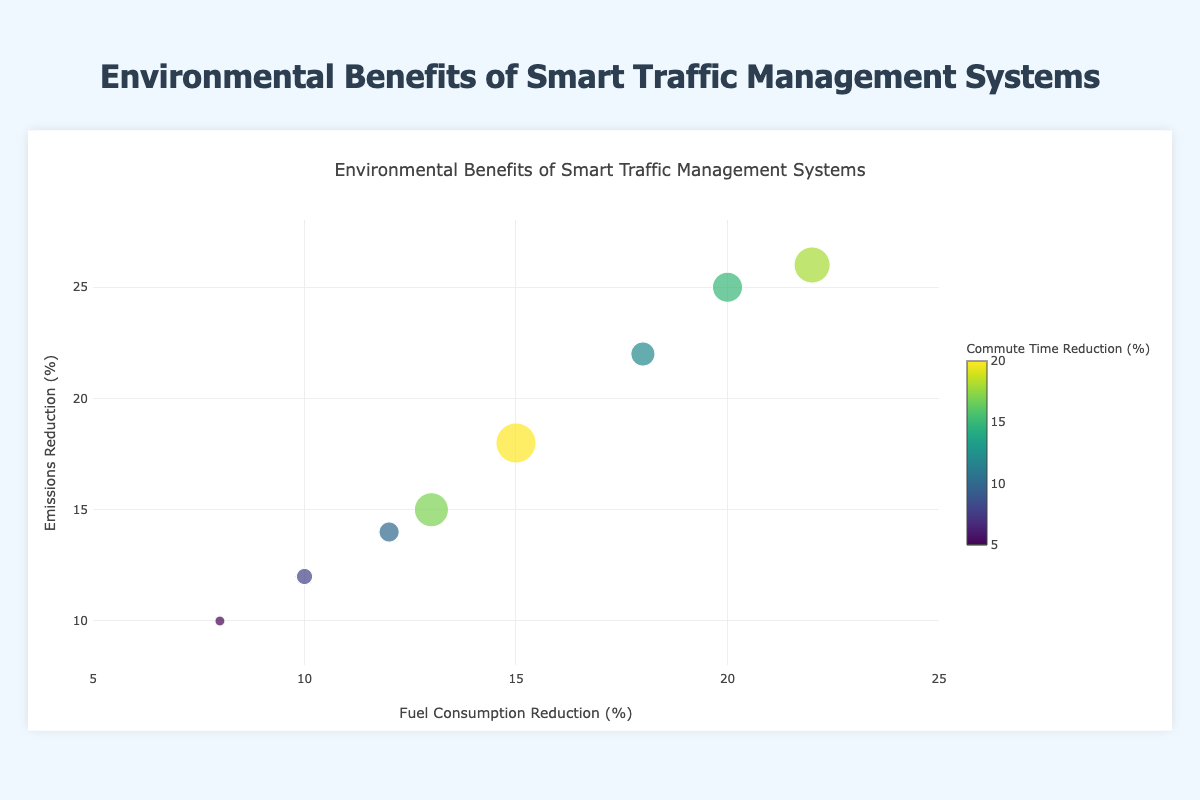What is the data point with the highest fuel consumption reduction? By observing the x-axis for the highest value, the data point labeled "Signal Optimization - Intersection C" has the highest fuel consumption reduction at 22%.
Answer: Signal Optimization - Intersection C What is the fuel consumption reduction for "Congestion Pricing - Downtown"? Locate "Congestion Pricing - Downtown" on the plot and check the x-axis value, which is 15%.
Answer: 15% Which data point has the least commute time reduction? Looking at the smallest size of the bubble, "Real-Time Data Analysis - Highway" has the least commute time reduction at 5%.
Answer: Real-Time Data Analysis - Highway How many data points fall within the range of 10% to 20% emissions reduction? Identify data points on the y-axis between 10% and 20%. The data points that fall within this range are "Congestion Pricing - Downtown" (18%), "Real-Time Data Analysis - Urban Area" (14%), "Real-Time Data Analysis - Suburban Area" (12%), "Congestion Pricing - Suburban Area" (15%), and "Real-Time Data Analysis - Highway" (10%). This counts to 5 data points.
Answer: 5 Which data point shows the highest emissions reduction and what is the corresponding commute time reduction? The highest emissions reduction on the y-axis is 26%, which corresponds to the bubble "Signal Optimization - Intersection C" with a commute time reduction of 18%.
Answer: Signal Optimization - Intersection C, 18% Compare the emissions reductions for "Signal Optimization - Intersection A" and "Congestion Pricing - Suburban Area". Which one is higher and by how much? "Signal Optimization - Intersection A" has an emissions reduction of 25%, and "Congestion Pricing - Suburban Area" has an emissions reduction of 15%. The difference is 25% - 15% = 10%. "Signal Optimization - Intersection A" is higher by 10%.
Answer: Signal Optimization - Intersection A, 10% What is the average commute time reduction for all the data points? Sum all commute time reductions: (15% + 12% + 20% + 10% + 8% + 17% + 18% + 5%) = 105%. Divide by the number of data points (8): 105% / 8 = 13.125%.
Answer: 13.125% Which strategy has the most consistent (similar) results in terms of emissions reduction across different areas? By comparing the y-axis values for the same strategy, "Real-Time Data Analysis" shows the smallest variability in emissions reduction with values of 14%, 12%, and 10%.
Answer: Real-Time Data Analysis How much more fuel consumption reduction does "Signal Optimization - Intersection C" have compared to "Real-Time Data Analysis - Urban Area"? "Signal Optimization - Intersection C" has 22% fuel consumption reduction, while "Real-Time Data Analysis - Urban Area" has 12%. The difference is 22% - 12% = 10%.
Answer: 10% Which two data points have similar bubble sizes and what are their corresponding commute time reductions? "Signal Optimization - Intersection A" and "Congestion Pricing - Suburban Area" have similar bubble sizes. Their commute time reductions are 15% and 17%, respectively.
Answer: Signal Optimization - Intersection A: 15%, Congestion Pricing - Suburban Area: 17% 